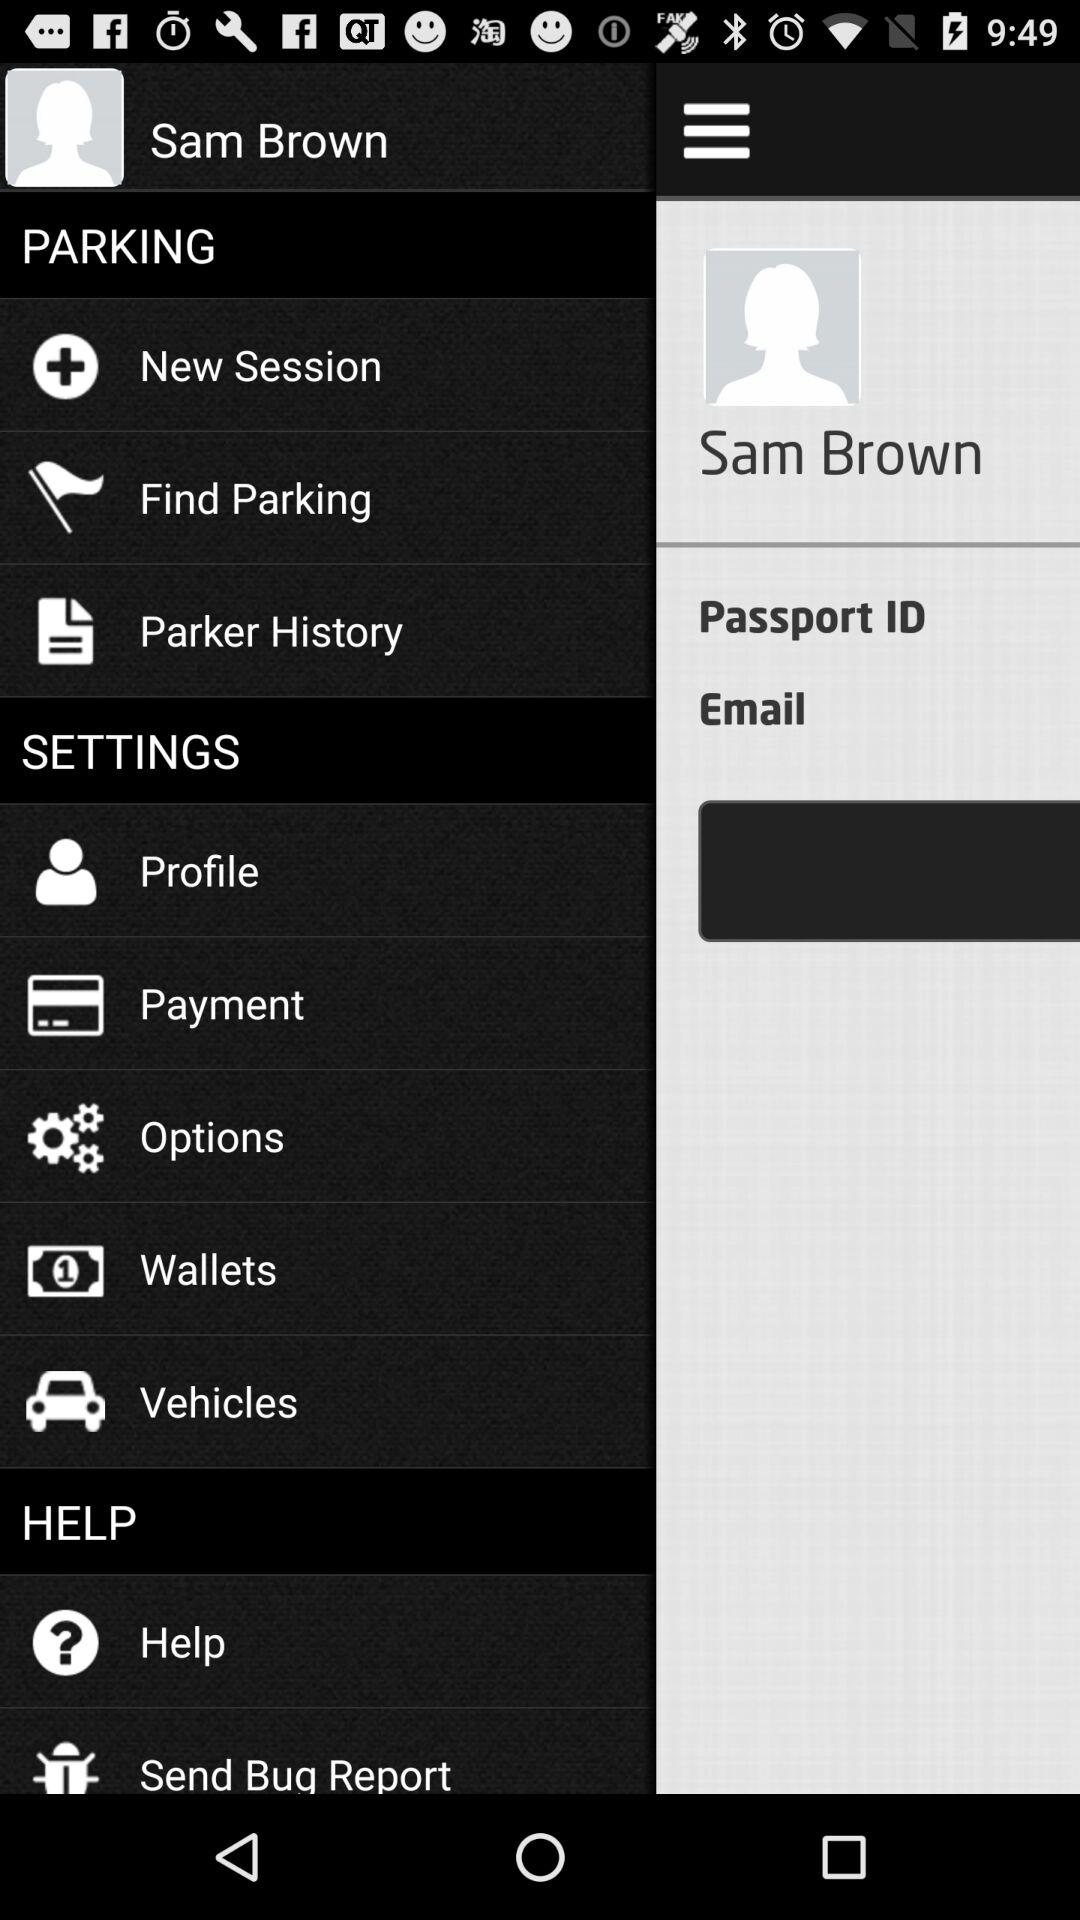What is the user's name? The user's name is Sam Brown. 